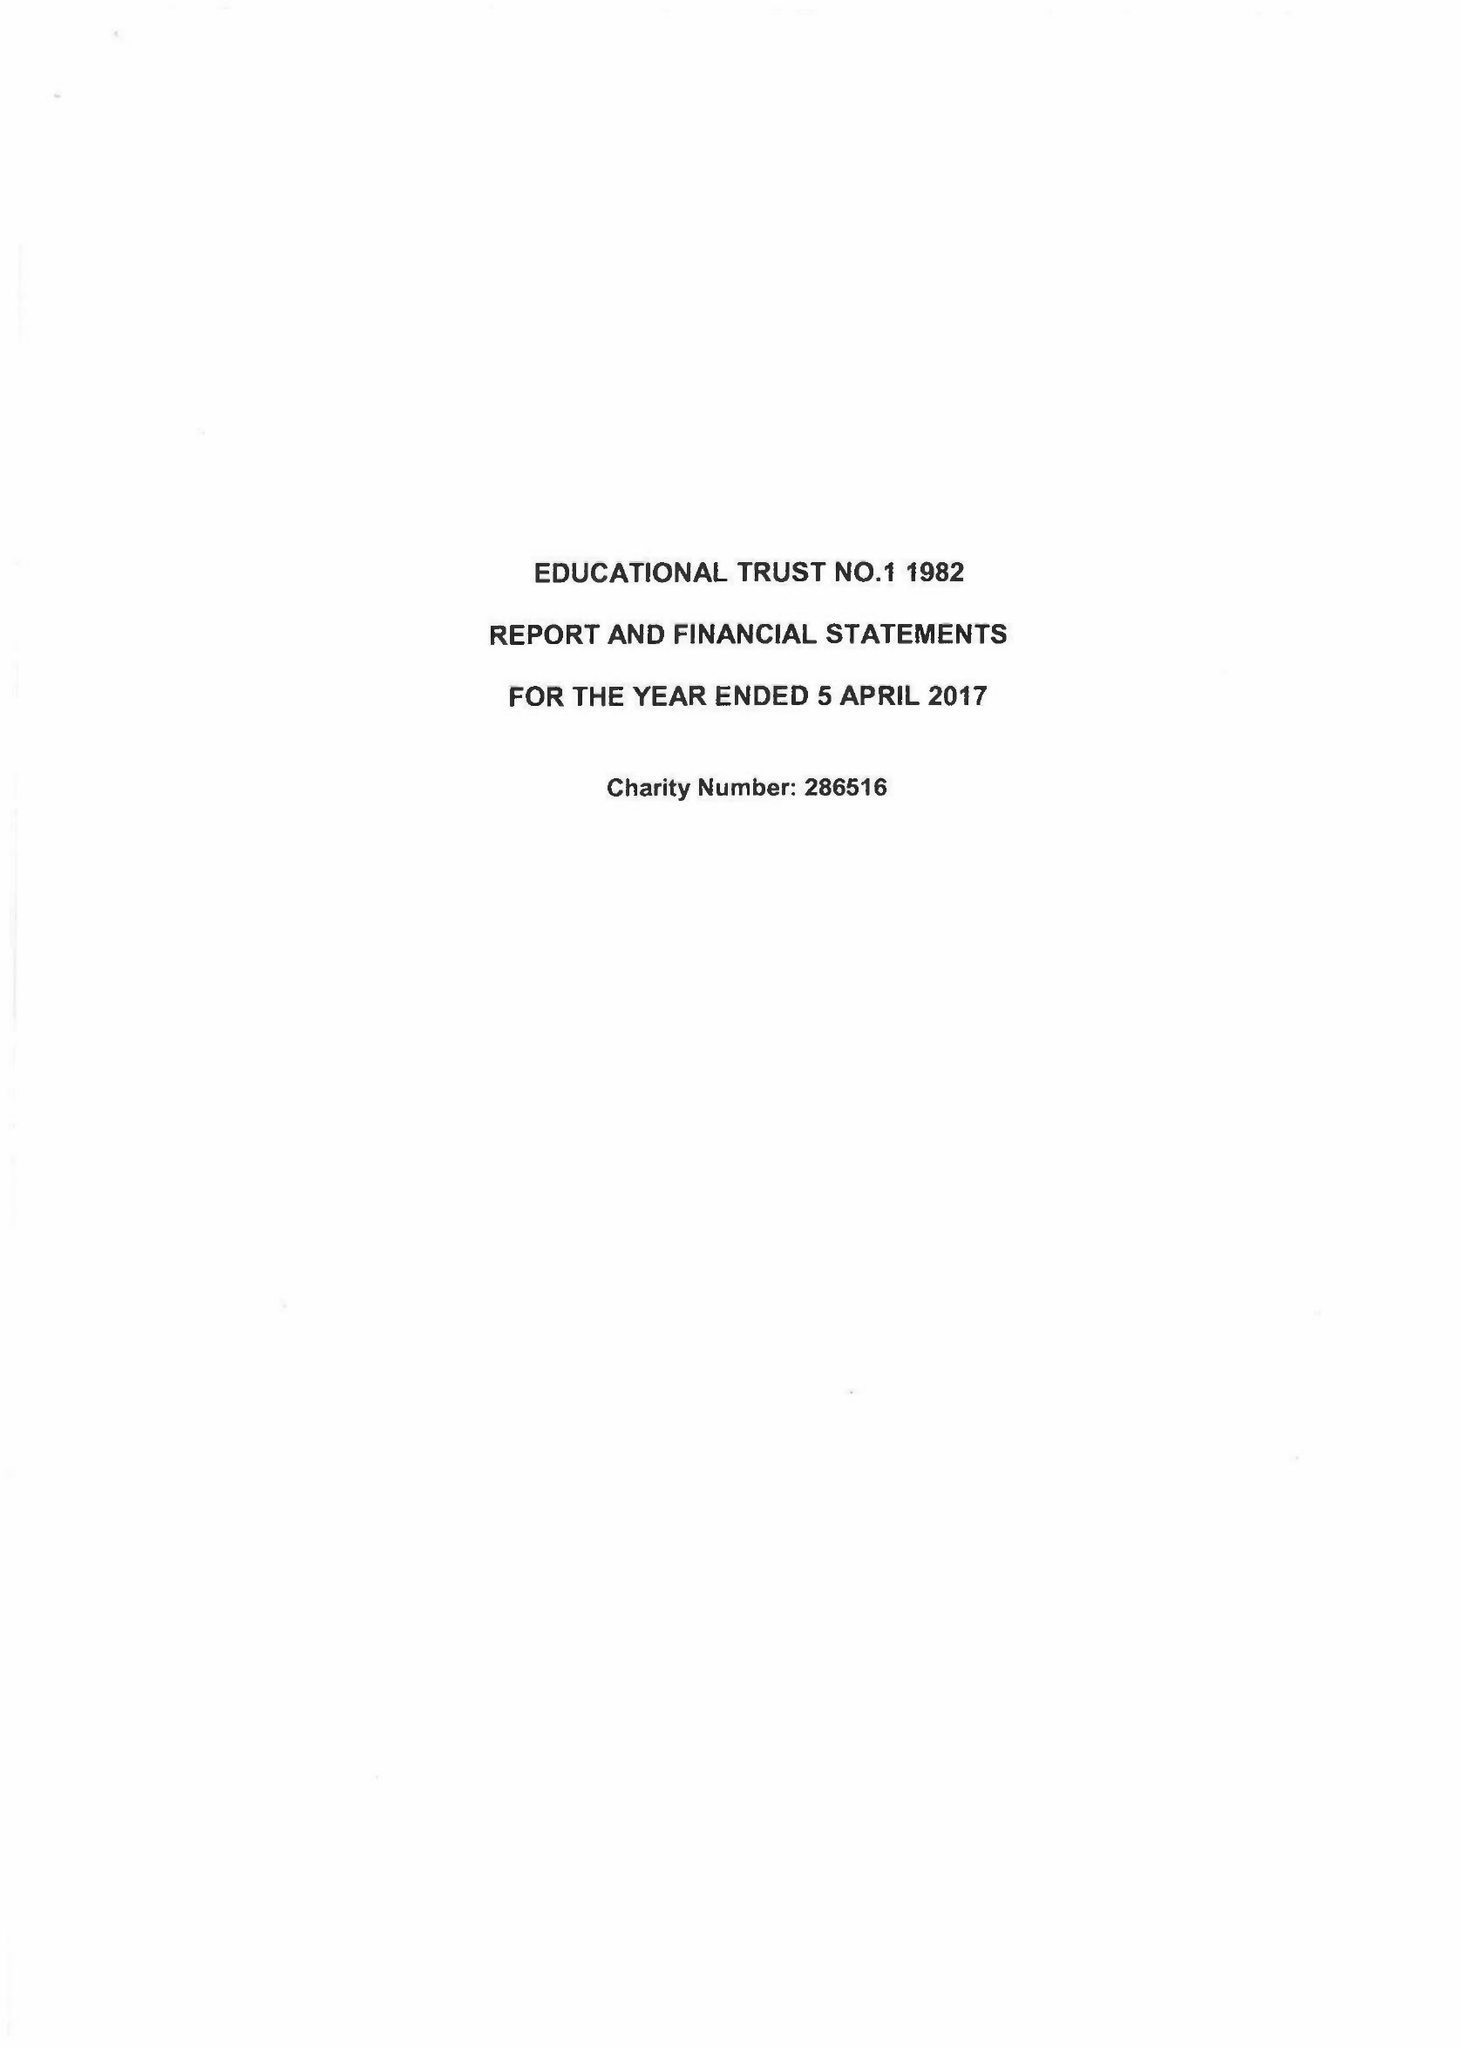What is the value for the address__post_town?
Answer the question using a single word or phrase. FAREHAM 